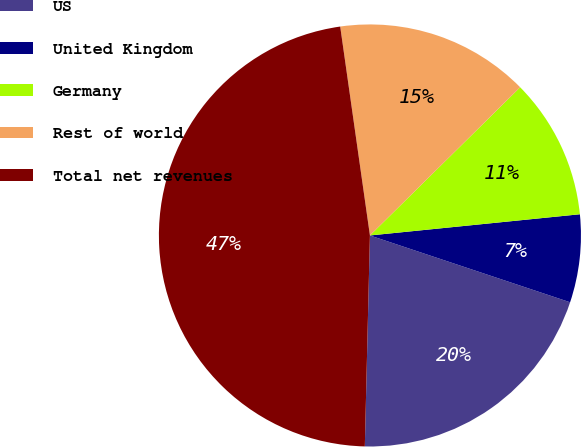Convert chart. <chart><loc_0><loc_0><loc_500><loc_500><pie_chart><fcel>US<fcel>United Kingdom<fcel>Germany<fcel>Rest of world<fcel>Total net revenues<nl><fcel>20.26%<fcel>6.73%<fcel>10.79%<fcel>14.86%<fcel>47.37%<nl></chart> 